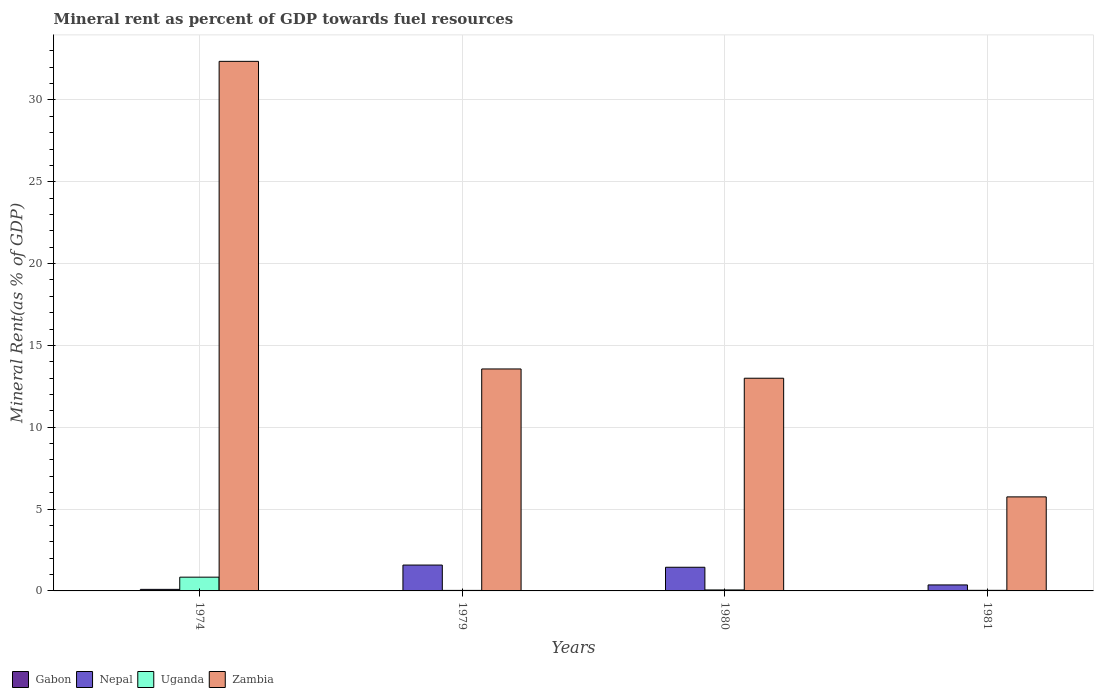How many different coloured bars are there?
Provide a short and direct response. 4. Are the number of bars per tick equal to the number of legend labels?
Offer a very short reply. Yes. How many bars are there on the 4th tick from the left?
Provide a short and direct response. 4. What is the label of the 3rd group of bars from the left?
Your answer should be compact. 1980. In how many cases, is the number of bars for a given year not equal to the number of legend labels?
Provide a succinct answer. 0. What is the mineral rent in Zambia in 1979?
Offer a very short reply. 13.56. Across all years, what is the maximum mineral rent in Gabon?
Offer a terse response. 0.01. Across all years, what is the minimum mineral rent in Gabon?
Give a very brief answer. 0. In which year was the mineral rent in Zambia maximum?
Your answer should be compact. 1974. In which year was the mineral rent in Zambia minimum?
Make the answer very short. 1981. What is the total mineral rent in Uganda in the graph?
Provide a short and direct response. 0.97. What is the difference between the mineral rent in Nepal in 1974 and that in 1980?
Provide a succinct answer. -1.35. What is the difference between the mineral rent in Zambia in 1981 and the mineral rent in Nepal in 1979?
Provide a short and direct response. 4.17. What is the average mineral rent in Gabon per year?
Offer a terse response. 0. In the year 1974, what is the difference between the mineral rent in Nepal and mineral rent in Uganda?
Your response must be concise. -0.75. What is the ratio of the mineral rent in Gabon in 1980 to that in 1981?
Your answer should be compact. 1.54. Is the mineral rent in Nepal in 1974 less than that in 1980?
Offer a terse response. Yes. Is the difference between the mineral rent in Nepal in 1974 and 1981 greater than the difference between the mineral rent in Uganda in 1974 and 1981?
Provide a succinct answer. No. What is the difference between the highest and the second highest mineral rent in Zambia?
Ensure brevity in your answer.  18.8. What is the difference between the highest and the lowest mineral rent in Zambia?
Give a very brief answer. 26.61. What does the 1st bar from the left in 1979 represents?
Provide a succinct answer. Gabon. What does the 2nd bar from the right in 1974 represents?
Make the answer very short. Uganda. Is it the case that in every year, the sum of the mineral rent in Uganda and mineral rent in Zambia is greater than the mineral rent in Nepal?
Offer a terse response. Yes. Does the graph contain any zero values?
Your answer should be very brief. No. Does the graph contain grids?
Provide a succinct answer. Yes. Where does the legend appear in the graph?
Offer a very short reply. Bottom left. How are the legend labels stacked?
Give a very brief answer. Horizontal. What is the title of the graph?
Ensure brevity in your answer.  Mineral rent as percent of GDP towards fuel resources. What is the label or title of the X-axis?
Give a very brief answer. Years. What is the label or title of the Y-axis?
Keep it short and to the point. Mineral Rent(as % of GDP). What is the Mineral Rent(as % of GDP) of Gabon in 1974?
Offer a very short reply. 0.01. What is the Mineral Rent(as % of GDP) of Nepal in 1974?
Offer a very short reply. 0.09. What is the Mineral Rent(as % of GDP) in Uganda in 1974?
Your answer should be compact. 0.84. What is the Mineral Rent(as % of GDP) of Zambia in 1974?
Give a very brief answer. 32.36. What is the Mineral Rent(as % of GDP) of Gabon in 1979?
Ensure brevity in your answer.  0. What is the Mineral Rent(as % of GDP) in Nepal in 1979?
Make the answer very short. 1.58. What is the Mineral Rent(as % of GDP) of Uganda in 1979?
Ensure brevity in your answer.  0.03. What is the Mineral Rent(as % of GDP) in Zambia in 1979?
Keep it short and to the point. 13.56. What is the Mineral Rent(as % of GDP) of Gabon in 1980?
Provide a succinct answer. 0. What is the Mineral Rent(as % of GDP) in Nepal in 1980?
Your response must be concise. 1.45. What is the Mineral Rent(as % of GDP) in Uganda in 1980?
Your response must be concise. 0.06. What is the Mineral Rent(as % of GDP) in Zambia in 1980?
Offer a terse response. 13. What is the Mineral Rent(as % of GDP) in Gabon in 1981?
Your answer should be compact. 0. What is the Mineral Rent(as % of GDP) in Nepal in 1981?
Give a very brief answer. 0.37. What is the Mineral Rent(as % of GDP) of Uganda in 1981?
Ensure brevity in your answer.  0.04. What is the Mineral Rent(as % of GDP) of Zambia in 1981?
Keep it short and to the point. 5.75. Across all years, what is the maximum Mineral Rent(as % of GDP) in Gabon?
Your answer should be very brief. 0.01. Across all years, what is the maximum Mineral Rent(as % of GDP) in Nepal?
Provide a short and direct response. 1.58. Across all years, what is the maximum Mineral Rent(as % of GDP) in Uganda?
Make the answer very short. 0.84. Across all years, what is the maximum Mineral Rent(as % of GDP) of Zambia?
Give a very brief answer. 32.36. Across all years, what is the minimum Mineral Rent(as % of GDP) in Gabon?
Give a very brief answer. 0. Across all years, what is the minimum Mineral Rent(as % of GDP) in Nepal?
Make the answer very short. 0.09. Across all years, what is the minimum Mineral Rent(as % of GDP) of Uganda?
Your response must be concise. 0.03. Across all years, what is the minimum Mineral Rent(as % of GDP) of Zambia?
Your answer should be compact. 5.75. What is the total Mineral Rent(as % of GDP) in Gabon in the graph?
Ensure brevity in your answer.  0.02. What is the total Mineral Rent(as % of GDP) of Nepal in the graph?
Offer a terse response. 3.49. What is the total Mineral Rent(as % of GDP) of Uganda in the graph?
Offer a terse response. 0.97. What is the total Mineral Rent(as % of GDP) of Zambia in the graph?
Ensure brevity in your answer.  64.66. What is the difference between the Mineral Rent(as % of GDP) of Gabon in 1974 and that in 1979?
Give a very brief answer. 0. What is the difference between the Mineral Rent(as % of GDP) in Nepal in 1974 and that in 1979?
Provide a succinct answer. -1.49. What is the difference between the Mineral Rent(as % of GDP) of Uganda in 1974 and that in 1979?
Your answer should be very brief. 0.81. What is the difference between the Mineral Rent(as % of GDP) of Zambia in 1974 and that in 1979?
Ensure brevity in your answer.  18.8. What is the difference between the Mineral Rent(as % of GDP) in Gabon in 1974 and that in 1980?
Keep it short and to the point. 0. What is the difference between the Mineral Rent(as % of GDP) in Nepal in 1974 and that in 1980?
Offer a terse response. -1.35. What is the difference between the Mineral Rent(as % of GDP) of Uganda in 1974 and that in 1980?
Give a very brief answer. 0.78. What is the difference between the Mineral Rent(as % of GDP) of Zambia in 1974 and that in 1980?
Your answer should be very brief. 19.36. What is the difference between the Mineral Rent(as % of GDP) in Gabon in 1974 and that in 1981?
Your answer should be compact. 0. What is the difference between the Mineral Rent(as % of GDP) of Nepal in 1974 and that in 1981?
Provide a succinct answer. -0.27. What is the difference between the Mineral Rent(as % of GDP) in Uganda in 1974 and that in 1981?
Offer a terse response. 0.8. What is the difference between the Mineral Rent(as % of GDP) of Zambia in 1974 and that in 1981?
Provide a short and direct response. 26.61. What is the difference between the Mineral Rent(as % of GDP) of Gabon in 1979 and that in 1980?
Provide a short and direct response. -0. What is the difference between the Mineral Rent(as % of GDP) in Nepal in 1979 and that in 1980?
Provide a succinct answer. 0.14. What is the difference between the Mineral Rent(as % of GDP) in Uganda in 1979 and that in 1980?
Give a very brief answer. -0.03. What is the difference between the Mineral Rent(as % of GDP) in Zambia in 1979 and that in 1980?
Give a very brief answer. 0.57. What is the difference between the Mineral Rent(as % of GDP) in Gabon in 1979 and that in 1981?
Offer a very short reply. -0. What is the difference between the Mineral Rent(as % of GDP) in Nepal in 1979 and that in 1981?
Offer a very short reply. 1.21. What is the difference between the Mineral Rent(as % of GDP) of Uganda in 1979 and that in 1981?
Ensure brevity in your answer.  -0. What is the difference between the Mineral Rent(as % of GDP) in Zambia in 1979 and that in 1981?
Your answer should be compact. 7.82. What is the difference between the Mineral Rent(as % of GDP) in Gabon in 1980 and that in 1981?
Offer a very short reply. 0. What is the difference between the Mineral Rent(as % of GDP) of Nepal in 1980 and that in 1981?
Ensure brevity in your answer.  1.08. What is the difference between the Mineral Rent(as % of GDP) of Uganda in 1980 and that in 1981?
Your answer should be very brief. 0.02. What is the difference between the Mineral Rent(as % of GDP) of Zambia in 1980 and that in 1981?
Your response must be concise. 7.25. What is the difference between the Mineral Rent(as % of GDP) in Gabon in 1974 and the Mineral Rent(as % of GDP) in Nepal in 1979?
Keep it short and to the point. -1.57. What is the difference between the Mineral Rent(as % of GDP) of Gabon in 1974 and the Mineral Rent(as % of GDP) of Uganda in 1979?
Ensure brevity in your answer.  -0.02. What is the difference between the Mineral Rent(as % of GDP) of Gabon in 1974 and the Mineral Rent(as % of GDP) of Zambia in 1979?
Your response must be concise. -13.55. What is the difference between the Mineral Rent(as % of GDP) of Nepal in 1974 and the Mineral Rent(as % of GDP) of Uganda in 1979?
Make the answer very short. 0.06. What is the difference between the Mineral Rent(as % of GDP) in Nepal in 1974 and the Mineral Rent(as % of GDP) in Zambia in 1979?
Provide a succinct answer. -13.47. What is the difference between the Mineral Rent(as % of GDP) of Uganda in 1974 and the Mineral Rent(as % of GDP) of Zambia in 1979?
Keep it short and to the point. -12.72. What is the difference between the Mineral Rent(as % of GDP) of Gabon in 1974 and the Mineral Rent(as % of GDP) of Nepal in 1980?
Your response must be concise. -1.44. What is the difference between the Mineral Rent(as % of GDP) in Gabon in 1974 and the Mineral Rent(as % of GDP) in Uganda in 1980?
Offer a terse response. -0.05. What is the difference between the Mineral Rent(as % of GDP) in Gabon in 1974 and the Mineral Rent(as % of GDP) in Zambia in 1980?
Offer a terse response. -12.99. What is the difference between the Mineral Rent(as % of GDP) of Nepal in 1974 and the Mineral Rent(as % of GDP) of Uganda in 1980?
Your response must be concise. 0.04. What is the difference between the Mineral Rent(as % of GDP) of Nepal in 1974 and the Mineral Rent(as % of GDP) of Zambia in 1980?
Provide a short and direct response. -12.9. What is the difference between the Mineral Rent(as % of GDP) in Uganda in 1974 and the Mineral Rent(as % of GDP) in Zambia in 1980?
Give a very brief answer. -12.16. What is the difference between the Mineral Rent(as % of GDP) of Gabon in 1974 and the Mineral Rent(as % of GDP) of Nepal in 1981?
Give a very brief answer. -0.36. What is the difference between the Mineral Rent(as % of GDP) of Gabon in 1974 and the Mineral Rent(as % of GDP) of Uganda in 1981?
Keep it short and to the point. -0.03. What is the difference between the Mineral Rent(as % of GDP) in Gabon in 1974 and the Mineral Rent(as % of GDP) in Zambia in 1981?
Make the answer very short. -5.74. What is the difference between the Mineral Rent(as % of GDP) of Nepal in 1974 and the Mineral Rent(as % of GDP) of Uganda in 1981?
Ensure brevity in your answer.  0.06. What is the difference between the Mineral Rent(as % of GDP) of Nepal in 1974 and the Mineral Rent(as % of GDP) of Zambia in 1981?
Offer a terse response. -5.65. What is the difference between the Mineral Rent(as % of GDP) in Uganda in 1974 and the Mineral Rent(as % of GDP) in Zambia in 1981?
Offer a terse response. -4.91. What is the difference between the Mineral Rent(as % of GDP) of Gabon in 1979 and the Mineral Rent(as % of GDP) of Nepal in 1980?
Offer a terse response. -1.44. What is the difference between the Mineral Rent(as % of GDP) of Gabon in 1979 and the Mineral Rent(as % of GDP) of Uganda in 1980?
Your answer should be very brief. -0.06. What is the difference between the Mineral Rent(as % of GDP) in Gabon in 1979 and the Mineral Rent(as % of GDP) in Zambia in 1980?
Your answer should be compact. -12.99. What is the difference between the Mineral Rent(as % of GDP) of Nepal in 1979 and the Mineral Rent(as % of GDP) of Uganda in 1980?
Keep it short and to the point. 1.52. What is the difference between the Mineral Rent(as % of GDP) of Nepal in 1979 and the Mineral Rent(as % of GDP) of Zambia in 1980?
Make the answer very short. -11.42. What is the difference between the Mineral Rent(as % of GDP) in Uganda in 1979 and the Mineral Rent(as % of GDP) in Zambia in 1980?
Give a very brief answer. -12.96. What is the difference between the Mineral Rent(as % of GDP) in Gabon in 1979 and the Mineral Rent(as % of GDP) in Nepal in 1981?
Provide a succinct answer. -0.36. What is the difference between the Mineral Rent(as % of GDP) of Gabon in 1979 and the Mineral Rent(as % of GDP) of Uganda in 1981?
Provide a short and direct response. -0.03. What is the difference between the Mineral Rent(as % of GDP) of Gabon in 1979 and the Mineral Rent(as % of GDP) of Zambia in 1981?
Offer a very short reply. -5.74. What is the difference between the Mineral Rent(as % of GDP) of Nepal in 1979 and the Mineral Rent(as % of GDP) of Uganda in 1981?
Offer a very short reply. 1.54. What is the difference between the Mineral Rent(as % of GDP) of Nepal in 1979 and the Mineral Rent(as % of GDP) of Zambia in 1981?
Provide a succinct answer. -4.17. What is the difference between the Mineral Rent(as % of GDP) of Uganda in 1979 and the Mineral Rent(as % of GDP) of Zambia in 1981?
Provide a short and direct response. -5.71. What is the difference between the Mineral Rent(as % of GDP) of Gabon in 1980 and the Mineral Rent(as % of GDP) of Nepal in 1981?
Keep it short and to the point. -0.36. What is the difference between the Mineral Rent(as % of GDP) of Gabon in 1980 and the Mineral Rent(as % of GDP) of Uganda in 1981?
Keep it short and to the point. -0.03. What is the difference between the Mineral Rent(as % of GDP) in Gabon in 1980 and the Mineral Rent(as % of GDP) in Zambia in 1981?
Make the answer very short. -5.74. What is the difference between the Mineral Rent(as % of GDP) of Nepal in 1980 and the Mineral Rent(as % of GDP) of Uganda in 1981?
Provide a short and direct response. 1.41. What is the difference between the Mineral Rent(as % of GDP) of Nepal in 1980 and the Mineral Rent(as % of GDP) of Zambia in 1981?
Keep it short and to the point. -4.3. What is the difference between the Mineral Rent(as % of GDP) in Uganda in 1980 and the Mineral Rent(as % of GDP) in Zambia in 1981?
Keep it short and to the point. -5.69. What is the average Mineral Rent(as % of GDP) in Gabon per year?
Give a very brief answer. 0. What is the average Mineral Rent(as % of GDP) in Nepal per year?
Your answer should be very brief. 0.87. What is the average Mineral Rent(as % of GDP) of Uganda per year?
Give a very brief answer. 0.24. What is the average Mineral Rent(as % of GDP) of Zambia per year?
Provide a succinct answer. 16.17. In the year 1974, what is the difference between the Mineral Rent(as % of GDP) in Gabon and Mineral Rent(as % of GDP) in Nepal?
Your response must be concise. -0.09. In the year 1974, what is the difference between the Mineral Rent(as % of GDP) of Gabon and Mineral Rent(as % of GDP) of Uganda?
Offer a very short reply. -0.83. In the year 1974, what is the difference between the Mineral Rent(as % of GDP) in Gabon and Mineral Rent(as % of GDP) in Zambia?
Ensure brevity in your answer.  -32.35. In the year 1974, what is the difference between the Mineral Rent(as % of GDP) of Nepal and Mineral Rent(as % of GDP) of Uganda?
Give a very brief answer. -0.75. In the year 1974, what is the difference between the Mineral Rent(as % of GDP) in Nepal and Mineral Rent(as % of GDP) in Zambia?
Your answer should be very brief. -32.26. In the year 1974, what is the difference between the Mineral Rent(as % of GDP) in Uganda and Mineral Rent(as % of GDP) in Zambia?
Your response must be concise. -31.52. In the year 1979, what is the difference between the Mineral Rent(as % of GDP) of Gabon and Mineral Rent(as % of GDP) of Nepal?
Make the answer very short. -1.58. In the year 1979, what is the difference between the Mineral Rent(as % of GDP) of Gabon and Mineral Rent(as % of GDP) of Uganda?
Provide a short and direct response. -0.03. In the year 1979, what is the difference between the Mineral Rent(as % of GDP) of Gabon and Mineral Rent(as % of GDP) of Zambia?
Provide a succinct answer. -13.56. In the year 1979, what is the difference between the Mineral Rent(as % of GDP) in Nepal and Mineral Rent(as % of GDP) in Uganda?
Provide a succinct answer. 1.55. In the year 1979, what is the difference between the Mineral Rent(as % of GDP) of Nepal and Mineral Rent(as % of GDP) of Zambia?
Your response must be concise. -11.98. In the year 1979, what is the difference between the Mineral Rent(as % of GDP) in Uganda and Mineral Rent(as % of GDP) in Zambia?
Your answer should be very brief. -13.53. In the year 1980, what is the difference between the Mineral Rent(as % of GDP) in Gabon and Mineral Rent(as % of GDP) in Nepal?
Your response must be concise. -1.44. In the year 1980, what is the difference between the Mineral Rent(as % of GDP) of Gabon and Mineral Rent(as % of GDP) of Uganda?
Offer a terse response. -0.05. In the year 1980, what is the difference between the Mineral Rent(as % of GDP) of Gabon and Mineral Rent(as % of GDP) of Zambia?
Offer a terse response. -12.99. In the year 1980, what is the difference between the Mineral Rent(as % of GDP) in Nepal and Mineral Rent(as % of GDP) in Uganda?
Make the answer very short. 1.39. In the year 1980, what is the difference between the Mineral Rent(as % of GDP) in Nepal and Mineral Rent(as % of GDP) in Zambia?
Keep it short and to the point. -11.55. In the year 1980, what is the difference between the Mineral Rent(as % of GDP) in Uganda and Mineral Rent(as % of GDP) in Zambia?
Keep it short and to the point. -12.94. In the year 1981, what is the difference between the Mineral Rent(as % of GDP) of Gabon and Mineral Rent(as % of GDP) of Nepal?
Offer a terse response. -0.36. In the year 1981, what is the difference between the Mineral Rent(as % of GDP) of Gabon and Mineral Rent(as % of GDP) of Uganda?
Keep it short and to the point. -0.03. In the year 1981, what is the difference between the Mineral Rent(as % of GDP) in Gabon and Mineral Rent(as % of GDP) in Zambia?
Your answer should be very brief. -5.74. In the year 1981, what is the difference between the Mineral Rent(as % of GDP) in Nepal and Mineral Rent(as % of GDP) in Uganda?
Provide a succinct answer. 0.33. In the year 1981, what is the difference between the Mineral Rent(as % of GDP) in Nepal and Mineral Rent(as % of GDP) in Zambia?
Make the answer very short. -5.38. In the year 1981, what is the difference between the Mineral Rent(as % of GDP) in Uganda and Mineral Rent(as % of GDP) in Zambia?
Ensure brevity in your answer.  -5.71. What is the ratio of the Mineral Rent(as % of GDP) of Gabon in 1974 to that in 1979?
Offer a terse response. 2.91. What is the ratio of the Mineral Rent(as % of GDP) of Nepal in 1974 to that in 1979?
Offer a very short reply. 0.06. What is the ratio of the Mineral Rent(as % of GDP) in Uganda in 1974 to that in 1979?
Offer a very short reply. 26. What is the ratio of the Mineral Rent(as % of GDP) in Zambia in 1974 to that in 1979?
Provide a succinct answer. 2.39. What is the ratio of the Mineral Rent(as % of GDP) of Gabon in 1974 to that in 1980?
Your answer should be compact. 1.63. What is the ratio of the Mineral Rent(as % of GDP) of Nepal in 1974 to that in 1980?
Give a very brief answer. 0.07. What is the ratio of the Mineral Rent(as % of GDP) in Uganda in 1974 to that in 1980?
Keep it short and to the point. 14.16. What is the ratio of the Mineral Rent(as % of GDP) in Zambia in 1974 to that in 1980?
Give a very brief answer. 2.49. What is the ratio of the Mineral Rent(as % of GDP) of Gabon in 1974 to that in 1981?
Offer a very short reply. 2.51. What is the ratio of the Mineral Rent(as % of GDP) of Nepal in 1974 to that in 1981?
Offer a terse response. 0.26. What is the ratio of the Mineral Rent(as % of GDP) in Uganda in 1974 to that in 1981?
Make the answer very short. 23.6. What is the ratio of the Mineral Rent(as % of GDP) of Zambia in 1974 to that in 1981?
Your answer should be compact. 5.63. What is the ratio of the Mineral Rent(as % of GDP) of Gabon in 1979 to that in 1980?
Your answer should be very brief. 0.56. What is the ratio of the Mineral Rent(as % of GDP) in Nepal in 1979 to that in 1980?
Your answer should be very brief. 1.09. What is the ratio of the Mineral Rent(as % of GDP) of Uganda in 1979 to that in 1980?
Your answer should be compact. 0.54. What is the ratio of the Mineral Rent(as % of GDP) of Zambia in 1979 to that in 1980?
Keep it short and to the point. 1.04. What is the ratio of the Mineral Rent(as % of GDP) of Gabon in 1979 to that in 1981?
Give a very brief answer. 0.86. What is the ratio of the Mineral Rent(as % of GDP) in Nepal in 1979 to that in 1981?
Your response must be concise. 4.32. What is the ratio of the Mineral Rent(as % of GDP) of Uganda in 1979 to that in 1981?
Provide a succinct answer. 0.91. What is the ratio of the Mineral Rent(as % of GDP) of Zambia in 1979 to that in 1981?
Provide a short and direct response. 2.36. What is the ratio of the Mineral Rent(as % of GDP) in Gabon in 1980 to that in 1981?
Provide a succinct answer. 1.54. What is the ratio of the Mineral Rent(as % of GDP) in Nepal in 1980 to that in 1981?
Your answer should be very brief. 3.95. What is the ratio of the Mineral Rent(as % of GDP) of Uganda in 1980 to that in 1981?
Provide a succinct answer. 1.67. What is the ratio of the Mineral Rent(as % of GDP) of Zambia in 1980 to that in 1981?
Provide a short and direct response. 2.26. What is the difference between the highest and the second highest Mineral Rent(as % of GDP) in Gabon?
Your answer should be very brief. 0. What is the difference between the highest and the second highest Mineral Rent(as % of GDP) in Nepal?
Provide a short and direct response. 0.14. What is the difference between the highest and the second highest Mineral Rent(as % of GDP) in Uganda?
Give a very brief answer. 0.78. What is the difference between the highest and the second highest Mineral Rent(as % of GDP) in Zambia?
Keep it short and to the point. 18.8. What is the difference between the highest and the lowest Mineral Rent(as % of GDP) of Gabon?
Offer a terse response. 0. What is the difference between the highest and the lowest Mineral Rent(as % of GDP) in Nepal?
Offer a terse response. 1.49. What is the difference between the highest and the lowest Mineral Rent(as % of GDP) of Uganda?
Provide a succinct answer. 0.81. What is the difference between the highest and the lowest Mineral Rent(as % of GDP) in Zambia?
Make the answer very short. 26.61. 